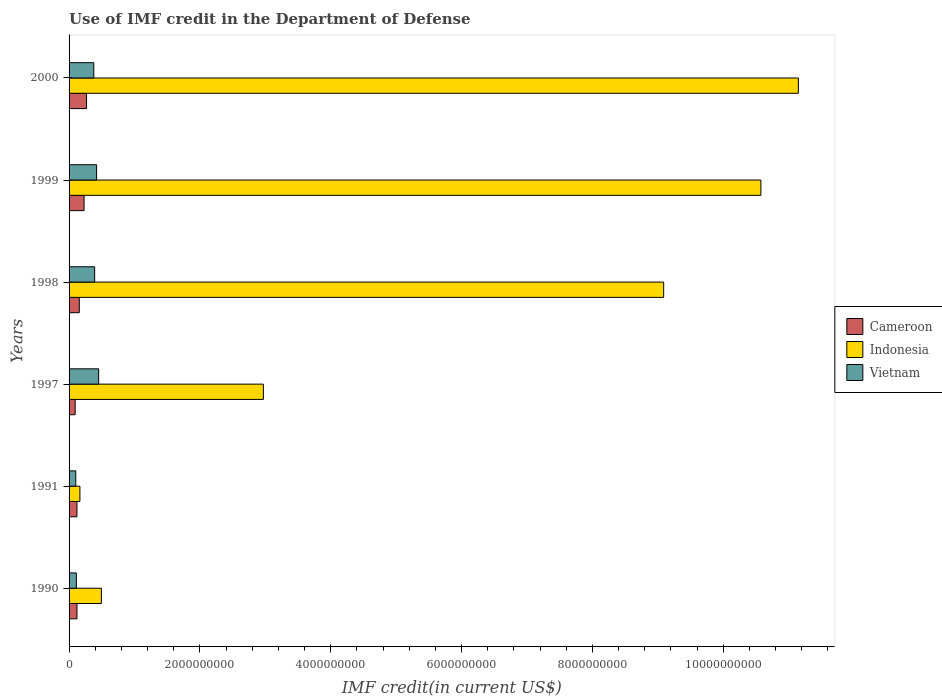How many different coloured bars are there?
Offer a very short reply. 3. Are the number of bars on each tick of the Y-axis equal?
Your answer should be very brief. Yes. How many bars are there on the 5th tick from the top?
Offer a terse response. 3. How many bars are there on the 6th tick from the bottom?
Your response must be concise. 3. What is the IMF credit in the Department of Defense in Indonesia in 2000?
Your answer should be compact. 1.11e+1. Across all years, what is the maximum IMF credit in the Department of Defense in Cameroon?
Your answer should be compact. 2.67e+08. Across all years, what is the minimum IMF credit in the Department of Defense in Cameroon?
Provide a short and direct response. 9.30e+07. In which year was the IMF credit in the Department of Defense in Indonesia maximum?
Your answer should be compact. 2000. In which year was the IMF credit in the Department of Defense in Indonesia minimum?
Give a very brief answer. 1991. What is the total IMF credit in the Department of Defense in Cameroon in the graph?
Your answer should be very brief. 9.87e+08. What is the difference between the IMF credit in the Department of Defense in Vietnam in 1997 and that in 2000?
Provide a short and direct response. 7.42e+07. What is the difference between the IMF credit in the Department of Defense in Indonesia in 2000 and the IMF credit in the Department of Defense in Vietnam in 1997?
Ensure brevity in your answer.  1.07e+1. What is the average IMF credit in the Department of Defense in Indonesia per year?
Offer a very short reply. 5.74e+09. In the year 1997, what is the difference between the IMF credit in the Department of Defense in Vietnam and IMF credit in the Department of Defense in Cameroon?
Provide a short and direct response. 3.59e+08. What is the ratio of the IMF credit in the Department of Defense in Vietnam in 1990 to that in 1991?
Your response must be concise. 1.09. What is the difference between the highest and the second highest IMF credit in the Department of Defense in Indonesia?
Provide a succinct answer. 5.73e+08. What is the difference between the highest and the lowest IMF credit in the Department of Defense in Vietnam?
Your response must be concise. 3.50e+08. In how many years, is the IMF credit in the Department of Defense in Cameroon greater than the average IMF credit in the Department of Defense in Cameroon taken over all years?
Your answer should be very brief. 2. What does the 3rd bar from the top in 1999 represents?
Provide a succinct answer. Cameroon. What does the 2nd bar from the bottom in 1991 represents?
Your response must be concise. Indonesia. How many bars are there?
Keep it short and to the point. 18. What is the difference between two consecutive major ticks on the X-axis?
Provide a short and direct response. 2.00e+09. Does the graph contain any zero values?
Your answer should be very brief. No. What is the title of the graph?
Ensure brevity in your answer.  Use of IMF credit in the Department of Defense. Does "India" appear as one of the legend labels in the graph?
Offer a very short reply. No. What is the label or title of the X-axis?
Offer a very short reply. IMF credit(in current US$). What is the label or title of the Y-axis?
Keep it short and to the point. Years. What is the IMF credit(in current US$) in Cameroon in 1990?
Your response must be concise. 1.21e+08. What is the IMF credit(in current US$) of Indonesia in 1990?
Make the answer very short. 4.94e+08. What is the IMF credit(in current US$) of Vietnam in 1990?
Your answer should be compact. 1.12e+08. What is the IMF credit(in current US$) of Cameroon in 1991?
Provide a short and direct response. 1.21e+08. What is the IMF credit(in current US$) in Indonesia in 1991?
Your response must be concise. 1.66e+08. What is the IMF credit(in current US$) of Vietnam in 1991?
Provide a succinct answer. 1.02e+08. What is the IMF credit(in current US$) of Cameroon in 1997?
Give a very brief answer. 9.30e+07. What is the IMF credit(in current US$) of Indonesia in 1997?
Your answer should be compact. 2.97e+09. What is the IMF credit(in current US$) of Vietnam in 1997?
Offer a terse response. 4.52e+08. What is the IMF credit(in current US$) of Cameroon in 1998?
Your answer should be compact. 1.56e+08. What is the IMF credit(in current US$) of Indonesia in 1998?
Provide a short and direct response. 9.09e+09. What is the IMF credit(in current US$) of Vietnam in 1998?
Provide a short and direct response. 3.91e+08. What is the IMF credit(in current US$) of Cameroon in 1999?
Provide a short and direct response. 2.29e+08. What is the IMF credit(in current US$) of Indonesia in 1999?
Keep it short and to the point. 1.06e+1. What is the IMF credit(in current US$) of Vietnam in 1999?
Provide a succinct answer. 4.20e+08. What is the IMF credit(in current US$) of Cameroon in 2000?
Provide a succinct answer. 2.67e+08. What is the IMF credit(in current US$) in Indonesia in 2000?
Keep it short and to the point. 1.11e+1. What is the IMF credit(in current US$) of Vietnam in 2000?
Give a very brief answer. 3.78e+08. Across all years, what is the maximum IMF credit(in current US$) in Cameroon?
Offer a very short reply. 2.67e+08. Across all years, what is the maximum IMF credit(in current US$) in Indonesia?
Offer a very short reply. 1.11e+1. Across all years, what is the maximum IMF credit(in current US$) in Vietnam?
Your answer should be very brief. 4.52e+08. Across all years, what is the minimum IMF credit(in current US$) in Cameroon?
Offer a very short reply. 9.30e+07. Across all years, what is the minimum IMF credit(in current US$) of Indonesia?
Your response must be concise. 1.66e+08. Across all years, what is the minimum IMF credit(in current US$) in Vietnam?
Keep it short and to the point. 1.02e+08. What is the total IMF credit(in current US$) of Cameroon in the graph?
Make the answer very short. 9.87e+08. What is the total IMF credit(in current US$) in Indonesia in the graph?
Offer a terse response. 3.44e+1. What is the total IMF credit(in current US$) in Vietnam in the graph?
Offer a terse response. 1.86e+09. What is the difference between the IMF credit(in current US$) in Cameroon in 1990 and that in 1991?
Provide a short and direct response. 5.17e+05. What is the difference between the IMF credit(in current US$) of Indonesia in 1990 and that in 1991?
Offer a terse response. 3.28e+08. What is the difference between the IMF credit(in current US$) of Vietnam in 1990 and that in 1991?
Keep it short and to the point. 9.36e+06. What is the difference between the IMF credit(in current US$) in Cameroon in 1990 and that in 1997?
Keep it short and to the point. 2.81e+07. What is the difference between the IMF credit(in current US$) in Indonesia in 1990 and that in 1997?
Offer a terse response. -2.48e+09. What is the difference between the IMF credit(in current US$) in Vietnam in 1990 and that in 1997?
Make the answer very short. -3.41e+08. What is the difference between the IMF credit(in current US$) in Cameroon in 1990 and that in 1998?
Keep it short and to the point. -3.51e+07. What is the difference between the IMF credit(in current US$) in Indonesia in 1990 and that in 1998?
Keep it short and to the point. -8.60e+09. What is the difference between the IMF credit(in current US$) in Vietnam in 1990 and that in 1998?
Your answer should be very brief. -2.80e+08. What is the difference between the IMF credit(in current US$) of Cameroon in 1990 and that in 1999?
Offer a very short reply. -1.08e+08. What is the difference between the IMF credit(in current US$) in Indonesia in 1990 and that in 1999?
Your response must be concise. -1.01e+1. What is the difference between the IMF credit(in current US$) in Vietnam in 1990 and that in 1999?
Your response must be concise. -3.09e+08. What is the difference between the IMF credit(in current US$) of Cameroon in 1990 and that in 2000?
Ensure brevity in your answer.  -1.46e+08. What is the difference between the IMF credit(in current US$) of Indonesia in 1990 and that in 2000?
Provide a short and direct response. -1.07e+1. What is the difference between the IMF credit(in current US$) in Vietnam in 1990 and that in 2000?
Your answer should be compact. -2.67e+08. What is the difference between the IMF credit(in current US$) in Cameroon in 1991 and that in 1997?
Your response must be concise. 2.76e+07. What is the difference between the IMF credit(in current US$) in Indonesia in 1991 and that in 1997?
Offer a terse response. -2.80e+09. What is the difference between the IMF credit(in current US$) in Vietnam in 1991 and that in 1997?
Give a very brief answer. -3.50e+08. What is the difference between the IMF credit(in current US$) in Cameroon in 1991 and that in 1998?
Your answer should be compact. -3.56e+07. What is the difference between the IMF credit(in current US$) of Indonesia in 1991 and that in 1998?
Offer a very short reply. -8.92e+09. What is the difference between the IMF credit(in current US$) of Vietnam in 1991 and that in 1998?
Ensure brevity in your answer.  -2.89e+08. What is the difference between the IMF credit(in current US$) in Cameroon in 1991 and that in 1999?
Make the answer very short. -1.09e+08. What is the difference between the IMF credit(in current US$) in Indonesia in 1991 and that in 1999?
Make the answer very short. -1.04e+1. What is the difference between the IMF credit(in current US$) of Vietnam in 1991 and that in 1999?
Offer a very short reply. -3.18e+08. What is the difference between the IMF credit(in current US$) of Cameroon in 1991 and that in 2000?
Keep it short and to the point. -1.46e+08. What is the difference between the IMF credit(in current US$) of Indonesia in 1991 and that in 2000?
Keep it short and to the point. -1.10e+1. What is the difference between the IMF credit(in current US$) of Vietnam in 1991 and that in 2000?
Your response must be concise. -2.76e+08. What is the difference between the IMF credit(in current US$) of Cameroon in 1997 and that in 1998?
Your answer should be very brief. -6.32e+07. What is the difference between the IMF credit(in current US$) of Indonesia in 1997 and that in 1998?
Provide a succinct answer. -6.12e+09. What is the difference between the IMF credit(in current US$) in Vietnam in 1997 and that in 1998?
Ensure brevity in your answer.  6.11e+07. What is the difference between the IMF credit(in current US$) of Cameroon in 1997 and that in 1999?
Offer a very short reply. -1.36e+08. What is the difference between the IMF credit(in current US$) in Indonesia in 1997 and that in 1999?
Make the answer very short. -7.61e+09. What is the difference between the IMF credit(in current US$) of Vietnam in 1997 and that in 1999?
Provide a short and direct response. 3.19e+07. What is the difference between the IMF credit(in current US$) in Cameroon in 1997 and that in 2000?
Offer a terse response. -1.74e+08. What is the difference between the IMF credit(in current US$) in Indonesia in 1997 and that in 2000?
Give a very brief answer. -8.18e+09. What is the difference between the IMF credit(in current US$) in Vietnam in 1997 and that in 2000?
Your response must be concise. 7.42e+07. What is the difference between the IMF credit(in current US$) of Cameroon in 1998 and that in 1999?
Ensure brevity in your answer.  -7.32e+07. What is the difference between the IMF credit(in current US$) of Indonesia in 1998 and that in 1999?
Keep it short and to the point. -1.49e+09. What is the difference between the IMF credit(in current US$) of Vietnam in 1998 and that in 1999?
Provide a succinct answer. -2.92e+07. What is the difference between the IMF credit(in current US$) of Cameroon in 1998 and that in 2000?
Your answer should be compact. -1.11e+08. What is the difference between the IMF credit(in current US$) in Indonesia in 1998 and that in 2000?
Your response must be concise. -2.06e+09. What is the difference between the IMF credit(in current US$) in Vietnam in 1998 and that in 2000?
Your answer should be compact. 1.31e+07. What is the difference between the IMF credit(in current US$) of Cameroon in 1999 and that in 2000?
Offer a very short reply. -3.77e+07. What is the difference between the IMF credit(in current US$) of Indonesia in 1999 and that in 2000?
Your answer should be very brief. -5.73e+08. What is the difference between the IMF credit(in current US$) of Vietnam in 1999 and that in 2000?
Keep it short and to the point. 4.23e+07. What is the difference between the IMF credit(in current US$) of Cameroon in 1990 and the IMF credit(in current US$) of Indonesia in 1991?
Keep it short and to the point. -4.45e+07. What is the difference between the IMF credit(in current US$) of Cameroon in 1990 and the IMF credit(in current US$) of Vietnam in 1991?
Make the answer very short. 1.88e+07. What is the difference between the IMF credit(in current US$) of Indonesia in 1990 and the IMF credit(in current US$) of Vietnam in 1991?
Give a very brief answer. 3.92e+08. What is the difference between the IMF credit(in current US$) of Cameroon in 1990 and the IMF credit(in current US$) of Indonesia in 1997?
Provide a succinct answer. -2.85e+09. What is the difference between the IMF credit(in current US$) in Cameroon in 1990 and the IMF credit(in current US$) in Vietnam in 1997?
Make the answer very short. -3.31e+08. What is the difference between the IMF credit(in current US$) of Indonesia in 1990 and the IMF credit(in current US$) of Vietnam in 1997?
Provide a short and direct response. 4.15e+07. What is the difference between the IMF credit(in current US$) in Cameroon in 1990 and the IMF credit(in current US$) in Indonesia in 1998?
Provide a succinct answer. -8.97e+09. What is the difference between the IMF credit(in current US$) in Cameroon in 1990 and the IMF credit(in current US$) in Vietnam in 1998?
Offer a very short reply. -2.70e+08. What is the difference between the IMF credit(in current US$) of Indonesia in 1990 and the IMF credit(in current US$) of Vietnam in 1998?
Provide a succinct answer. 1.03e+08. What is the difference between the IMF credit(in current US$) in Cameroon in 1990 and the IMF credit(in current US$) in Indonesia in 1999?
Provide a succinct answer. -1.05e+1. What is the difference between the IMF credit(in current US$) in Cameroon in 1990 and the IMF credit(in current US$) in Vietnam in 1999?
Provide a short and direct response. -2.99e+08. What is the difference between the IMF credit(in current US$) of Indonesia in 1990 and the IMF credit(in current US$) of Vietnam in 1999?
Offer a very short reply. 7.34e+07. What is the difference between the IMF credit(in current US$) in Cameroon in 1990 and the IMF credit(in current US$) in Indonesia in 2000?
Make the answer very short. -1.10e+1. What is the difference between the IMF credit(in current US$) in Cameroon in 1990 and the IMF credit(in current US$) in Vietnam in 2000?
Give a very brief answer. -2.57e+08. What is the difference between the IMF credit(in current US$) of Indonesia in 1990 and the IMF credit(in current US$) of Vietnam in 2000?
Keep it short and to the point. 1.16e+08. What is the difference between the IMF credit(in current US$) of Cameroon in 1991 and the IMF credit(in current US$) of Indonesia in 1997?
Ensure brevity in your answer.  -2.85e+09. What is the difference between the IMF credit(in current US$) of Cameroon in 1991 and the IMF credit(in current US$) of Vietnam in 1997?
Ensure brevity in your answer.  -3.32e+08. What is the difference between the IMF credit(in current US$) in Indonesia in 1991 and the IMF credit(in current US$) in Vietnam in 1997?
Provide a succinct answer. -2.87e+08. What is the difference between the IMF credit(in current US$) in Cameroon in 1991 and the IMF credit(in current US$) in Indonesia in 1998?
Your response must be concise. -8.97e+09. What is the difference between the IMF credit(in current US$) in Cameroon in 1991 and the IMF credit(in current US$) in Vietnam in 1998?
Give a very brief answer. -2.71e+08. What is the difference between the IMF credit(in current US$) in Indonesia in 1991 and the IMF credit(in current US$) in Vietnam in 1998?
Offer a very short reply. -2.26e+08. What is the difference between the IMF credit(in current US$) in Cameroon in 1991 and the IMF credit(in current US$) in Indonesia in 1999?
Provide a succinct answer. -1.05e+1. What is the difference between the IMF credit(in current US$) of Cameroon in 1991 and the IMF credit(in current US$) of Vietnam in 1999?
Your answer should be compact. -3.00e+08. What is the difference between the IMF credit(in current US$) of Indonesia in 1991 and the IMF credit(in current US$) of Vietnam in 1999?
Your response must be concise. -2.55e+08. What is the difference between the IMF credit(in current US$) of Cameroon in 1991 and the IMF credit(in current US$) of Indonesia in 2000?
Provide a succinct answer. -1.10e+1. What is the difference between the IMF credit(in current US$) of Cameroon in 1991 and the IMF credit(in current US$) of Vietnam in 2000?
Provide a short and direct response. -2.58e+08. What is the difference between the IMF credit(in current US$) of Indonesia in 1991 and the IMF credit(in current US$) of Vietnam in 2000?
Provide a succinct answer. -2.13e+08. What is the difference between the IMF credit(in current US$) in Cameroon in 1997 and the IMF credit(in current US$) in Indonesia in 1998?
Give a very brief answer. -9.00e+09. What is the difference between the IMF credit(in current US$) in Cameroon in 1997 and the IMF credit(in current US$) in Vietnam in 1998?
Keep it short and to the point. -2.98e+08. What is the difference between the IMF credit(in current US$) in Indonesia in 1997 and the IMF credit(in current US$) in Vietnam in 1998?
Keep it short and to the point. 2.58e+09. What is the difference between the IMF credit(in current US$) in Cameroon in 1997 and the IMF credit(in current US$) in Indonesia in 1999?
Your answer should be compact. -1.05e+1. What is the difference between the IMF credit(in current US$) of Cameroon in 1997 and the IMF credit(in current US$) of Vietnam in 1999?
Provide a succinct answer. -3.28e+08. What is the difference between the IMF credit(in current US$) of Indonesia in 1997 and the IMF credit(in current US$) of Vietnam in 1999?
Your response must be concise. 2.55e+09. What is the difference between the IMF credit(in current US$) in Cameroon in 1997 and the IMF credit(in current US$) in Indonesia in 2000?
Your answer should be very brief. -1.11e+1. What is the difference between the IMF credit(in current US$) in Cameroon in 1997 and the IMF credit(in current US$) in Vietnam in 2000?
Your answer should be very brief. -2.85e+08. What is the difference between the IMF credit(in current US$) in Indonesia in 1997 and the IMF credit(in current US$) in Vietnam in 2000?
Offer a very short reply. 2.59e+09. What is the difference between the IMF credit(in current US$) in Cameroon in 1998 and the IMF credit(in current US$) in Indonesia in 1999?
Give a very brief answer. -1.04e+1. What is the difference between the IMF credit(in current US$) in Cameroon in 1998 and the IMF credit(in current US$) in Vietnam in 1999?
Your answer should be compact. -2.64e+08. What is the difference between the IMF credit(in current US$) of Indonesia in 1998 and the IMF credit(in current US$) of Vietnam in 1999?
Offer a terse response. 8.67e+09. What is the difference between the IMF credit(in current US$) of Cameroon in 1998 and the IMF credit(in current US$) of Indonesia in 2000?
Offer a very short reply. -1.10e+1. What is the difference between the IMF credit(in current US$) of Cameroon in 1998 and the IMF credit(in current US$) of Vietnam in 2000?
Offer a terse response. -2.22e+08. What is the difference between the IMF credit(in current US$) in Indonesia in 1998 and the IMF credit(in current US$) in Vietnam in 2000?
Give a very brief answer. 8.71e+09. What is the difference between the IMF credit(in current US$) of Cameroon in 1999 and the IMF credit(in current US$) of Indonesia in 2000?
Give a very brief answer. -1.09e+1. What is the difference between the IMF credit(in current US$) in Cameroon in 1999 and the IMF credit(in current US$) in Vietnam in 2000?
Your response must be concise. -1.49e+08. What is the difference between the IMF credit(in current US$) of Indonesia in 1999 and the IMF credit(in current US$) of Vietnam in 2000?
Give a very brief answer. 1.02e+1. What is the average IMF credit(in current US$) of Cameroon per year?
Keep it short and to the point. 1.65e+08. What is the average IMF credit(in current US$) of Indonesia per year?
Your answer should be compact. 5.74e+09. What is the average IMF credit(in current US$) in Vietnam per year?
Keep it short and to the point. 3.09e+08. In the year 1990, what is the difference between the IMF credit(in current US$) in Cameroon and IMF credit(in current US$) in Indonesia?
Your response must be concise. -3.73e+08. In the year 1990, what is the difference between the IMF credit(in current US$) of Cameroon and IMF credit(in current US$) of Vietnam?
Offer a terse response. 9.39e+06. In the year 1990, what is the difference between the IMF credit(in current US$) in Indonesia and IMF credit(in current US$) in Vietnam?
Your answer should be very brief. 3.82e+08. In the year 1991, what is the difference between the IMF credit(in current US$) in Cameroon and IMF credit(in current US$) in Indonesia?
Provide a short and direct response. -4.50e+07. In the year 1991, what is the difference between the IMF credit(in current US$) in Cameroon and IMF credit(in current US$) in Vietnam?
Your answer should be very brief. 1.82e+07. In the year 1991, what is the difference between the IMF credit(in current US$) of Indonesia and IMF credit(in current US$) of Vietnam?
Your response must be concise. 6.32e+07. In the year 1997, what is the difference between the IMF credit(in current US$) in Cameroon and IMF credit(in current US$) in Indonesia?
Your response must be concise. -2.88e+09. In the year 1997, what is the difference between the IMF credit(in current US$) in Cameroon and IMF credit(in current US$) in Vietnam?
Offer a terse response. -3.59e+08. In the year 1997, what is the difference between the IMF credit(in current US$) in Indonesia and IMF credit(in current US$) in Vietnam?
Ensure brevity in your answer.  2.52e+09. In the year 1998, what is the difference between the IMF credit(in current US$) of Cameroon and IMF credit(in current US$) of Indonesia?
Offer a terse response. -8.93e+09. In the year 1998, what is the difference between the IMF credit(in current US$) of Cameroon and IMF credit(in current US$) of Vietnam?
Provide a short and direct response. -2.35e+08. In the year 1998, what is the difference between the IMF credit(in current US$) of Indonesia and IMF credit(in current US$) of Vietnam?
Offer a very short reply. 8.70e+09. In the year 1999, what is the difference between the IMF credit(in current US$) in Cameroon and IMF credit(in current US$) in Indonesia?
Keep it short and to the point. -1.03e+1. In the year 1999, what is the difference between the IMF credit(in current US$) in Cameroon and IMF credit(in current US$) in Vietnam?
Give a very brief answer. -1.91e+08. In the year 1999, what is the difference between the IMF credit(in current US$) in Indonesia and IMF credit(in current US$) in Vietnam?
Offer a terse response. 1.02e+1. In the year 2000, what is the difference between the IMF credit(in current US$) of Cameroon and IMF credit(in current US$) of Indonesia?
Make the answer very short. -1.09e+1. In the year 2000, what is the difference between the IMF credit(in current US$) of Cameroon and IMF credit(in current US$) of Vietnam?
Ensure brevity in your answer.  -1.11e+08. In the year 2000, what is the difference between the IMF credit(in current US$) of Indonesia and IMF credit(in current US$) of Vietnam?
Give a very brief answer. 1.08e+1. What is the ratio of the IMF credit(in current US$) of Cameroon in 1990 to that in 1991?
Your response must be concise. 1. What is the ratio of the IMF credit(in current US$) of Indonesia in 1990 to that in 1991?
Offer a very short reply. 2.98. What is the ratio of the IMF credit(in current US$) of Vietnam in 1990 to that in 1991?
Provide a succinct answer. 1.09. What is the ratio of the IMF credit(in current US$) of Cameroon in 1990 to that in 1997?
Offer a very short reply. 1.3. What is the ratio of the IMF credit(in current US$) of Indonesia in 1990 to that in 1997?
Ensure brevity in your answer.  0.17. What is the ratio of the IMF credit(in current US$) in Vietnam in 1990 to that in 1997?
Your answer should be very brief. 0.25. What is the ratio of the IMF credit(in current US$) in Cameroon in 1990 to that in 1998?
Provide a succinct answer. 0.78. What is the ratio of the IMF credit(in current US$) in Indonesia in 1990 to that in 1998?
Your answer should be compact. 0.05. What is the ratio of the IMF credit(in current US$) in Vietnam in 1990 to that in 1998?
Your answer should be very brief. 0.29. What is the ratio of the IMF credit(in current US$) in Cameroon in 1990 to that in 1999?
Give a very brief answer. 0.53. What is the ratio of the IMF credit(in current US$) of Indonesia in 1990 to that in 1999?
Make the answer very short. 0.05. What is the ratio of the IMF credit(in current US$) of Vietnam in 1990 to that in 1999?
Your response must be concise. 0.27. What is the ratio of the IMF credit(in current US$) in Cameroon in 1990 to that in 2000?
Offer a terse response. 0.45. What is the ratio of the IMF credit(in current US$) in Indonesia in 1990 to that in 2000?
Your response must be concise. 0.04. What is the ratio of the IMF credit(in current US$) in Vietnam in 1990 to that in 2000?
Offer a very short reply. 0.3. What is the ratio of the IMF credit(in current US$) of Cameroon in 1991 to that in 1997?
Keep it short and to the point. 1.3. What is the ratio of the IMF credit(in current US$) of Indonesia in 1991 to that in 1997?
Make the answer very short. 0.06. What is the ratio of the IMF credit(in current US$) of Vietnam in 1991 to that in 1997?
Provide a succinct answer. 0.23. What is the ratio of the IMF credit(in current US$) in Cameroon in 1991 to that in 1998?
Make the answer very short. 0.77. What is the ratio of the IMF credit(in current US$) in Indonesia in 1991 to that in 1998?
Keep it short and to the point. 0.02. What is the ratio of the IMF credit(in current US$) of Vietnam in 1991 to that in 1998?
Offer a very short reply. 0.26. What is the ratio of the IMF credit(in current US$) in Cameroon in 1991 to that in 1999?
Keep it short and to the point. 0.53. What is the ratio of the IMF credit(in current US$) of Indonesia in 1991 to that in 1999?
Your answer should be compact. 0.02. What is the ratio of the IMF credit(in current US$) of Vietnam in 1991 to that in 1999?
Keep it short and to the point. 0.24. What is the ratio of the IMF credit(in current US$) in Cameroon in 1991 to that in 2000?
Offer a very short reply. 0.45. What is the ratio of the IMF credit(in current US$) of Indonesia in 1991 to that in 2000?
Your answer should be very brief. 0.01. What is the ratio of the IMF credit(in current US$) in Vietnam in 1991 to that in 2000?
Give a very brief answer. 0.27. What is the ratio of the IMF credit(in current US$) of Cameroon in 1997 to that in 1998?
Offer a terse response. 0.6. What is the ratio of the IMF credit(in current US$) of Indonesia in 1997 to that in 1998?
Provide a succinct answer. 0.33. What is the ratio of the IMF credit(in current US$) of Vietnam in 1997 to that in 1998?
Make the answer very short. 1.16. What is the ratio of the IMF credit(in current US$) in Cameroon in 1997 to that in 1999?
Offer a very short reply. 0.41. What is the ratio of the IMF credit(in current US$) of Indonesia in 1997 to that in 1999?
Ensure brevity in your answer.  0.28. What is the ratio of the IMF credit(in current US$) in Vietnam in 1997 to that in 1999?
Offer a very short reply. 1.08. What is the ratio of the IMF credit(in current US$) of Cameroon in 1997 to that in 2000?
Provide a short and direct response. 0.35. What is the ratio of the IMF credit(in current US$) in Indonesia in 1997 to that in 2000?
Give a very brief answer. 0.27. What is the ratio of the IMF credit(in current US$) of Vietnam in 1997 to that in 2000?
Offer a terse response. 1.2. What is the ratio of the IMF credit(in current US$) in Cameroon in 1998 to that in 1999?
Give a very brief answer. 0.68. What is the ratio of the IMF credit(in current US$) of Indonesia in 1998 to that in 1999?
Keep it short and to the point. 0.86. What is the ratio of the IMF credit(in current US$) of Vietnam in 1998 to that in 1999?
Your answer should be very brief. 0.93. What is the ratio of the IMF credit(in current US$) in Cameroon in 1998 to that in 2000?
Provide a short and direct response. 0.58. What is the ratio of the IMF credit(in current US$) of Indonesia in 1998 to that in 2000?
Offer a very short reply. 0.82. What is the ratio of the IMF credit(in current US$) in Vietnam in 1998 to that in 2000?
Your answer should be compact. 1.03. What is the ratio of the IMF credit(in current US$) in Cameroon in 1999 to that in 2000?
Make the answer very short. 0.86. What is the ratio of the IMF credit(in current US$) in Indonesia in 1999 to that in 2000?
Your answer should be compact. 0.95. What is the ratio of the IMF credit(in current US$) in Vietnam in 1999 to that in 2000?
Keep it short and to the point. 1.11. What is the difference between the highest and the second highest IMF credit(in current US$) of Cameroon?
Offer a very short reply. 3.77e+07. What is the difference between the highest and the second highest IMF credit(in current US$) in Indonesia?
Keep it short and to the point. 5.73e+08. What is the difference between the highest and the second highest IMF credit(in current US$) in Vietnam?
Your answer should be compact. 3.19e+07. What is the difference between the highest and the lowest IMF credit(in current US$) in Cameroon?
Ensure brevity in your answer.  1.74e+08. What is the difference between the highest and the lowest IMF credit(in current US$) in Indonesia?
Give a very brief answer. 1.10e+1. What is the difference between the highest and the lowest IMF credit(in current US$) in Vietnam?
Provide a succinct answer. 3.50e+08. 